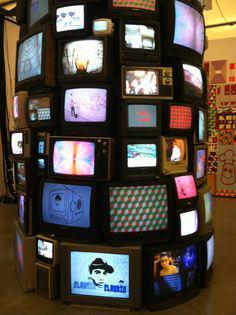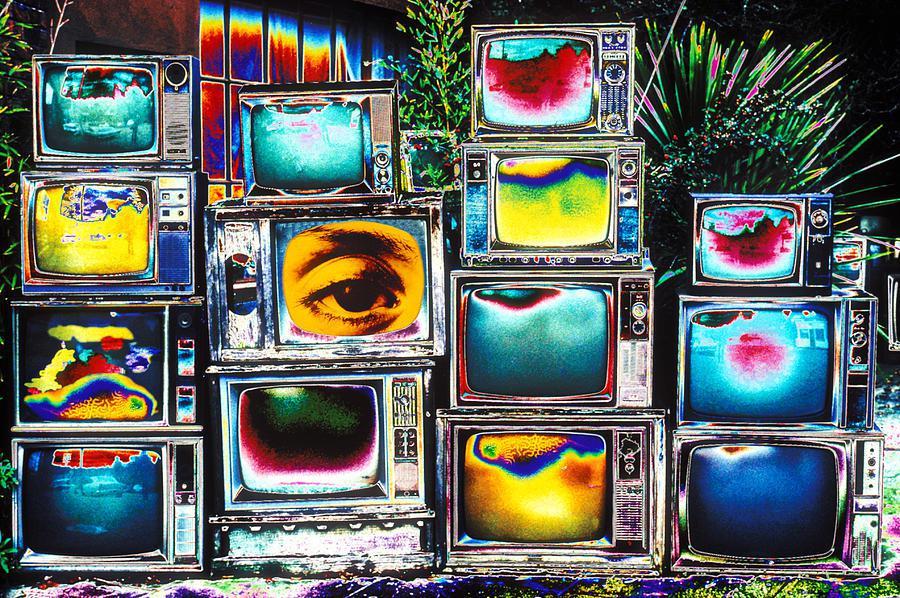The first image is the image on the left, the second image is the image on the right. For the images displayed, is the sentence "In one image there are television sets being displayed as art arranged in a column." factually correct? Answer yes or no. Yes. The first image is the image on the left, the second image is the image on the right. Considering the images on both sides, is "One of the images has less than ten TVs." valid? Answer yes or no. No. 